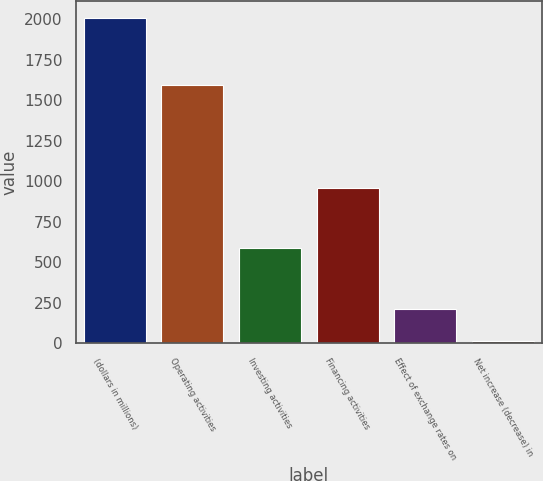Convert chart to OTSL. <chart><loc_0><loc_0><loc_500><loc_500><bar_chart><fcel>(dollars in millions)<fcel>Operating activities<fcel>Investing activities<fcel>Financing activities<fcel>Effect of exchange rates on<fcel>Net increase (decrease) in<nl><fcel>2011<fcel>1595<fcel>587<fcel>957<fcel>215.5<fcel>16<nl></chart> 